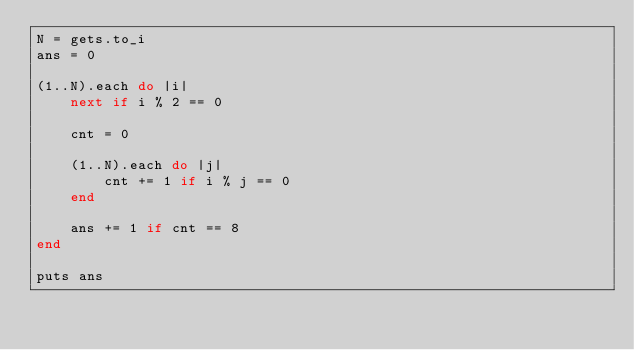Convert code to text. <code><loc_0><loc_0><loc_500><loc_500><_Ruby_>N = gets.to_i
ans = 0

(1..N).each do |i|
    next if i % 2 == 0

    cnt = 0

    (1..N).each do |j|
        cnt += 1 if i % j == 0
    end

    ans += 1 if cnt == 8
end

puts ans</code> 